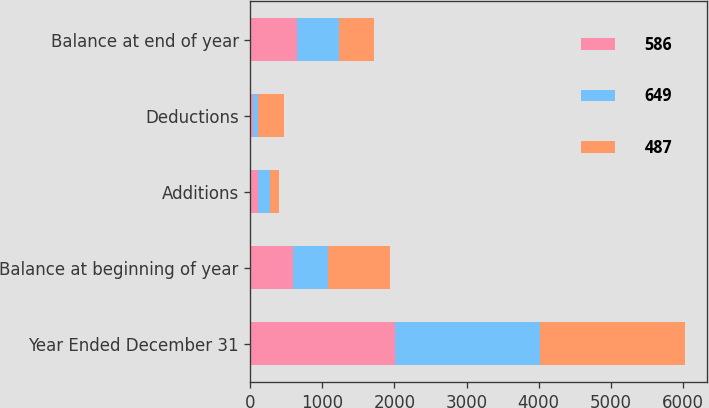<chart> <loc_0><loc_0><loc_500><loc_500><stacked_bar_chart><ecel><fcel>Year Ended December 31<fcel>Balance at beginning of year<fcel>Additions<fcel>Deductions<fcel>Balance at end of year<nl><fcel>586<fcel>2014<fcel>586<fcel>104<fcel>41<fcel>649<nl><fcel>649<fcel>2013<fcel>487<fcel>169<fcel>70<fcel>586<nl><fcel>487<fcel>2012<fcel>859<fcel>126<fcel>352<fcel>487<nl></chart> 